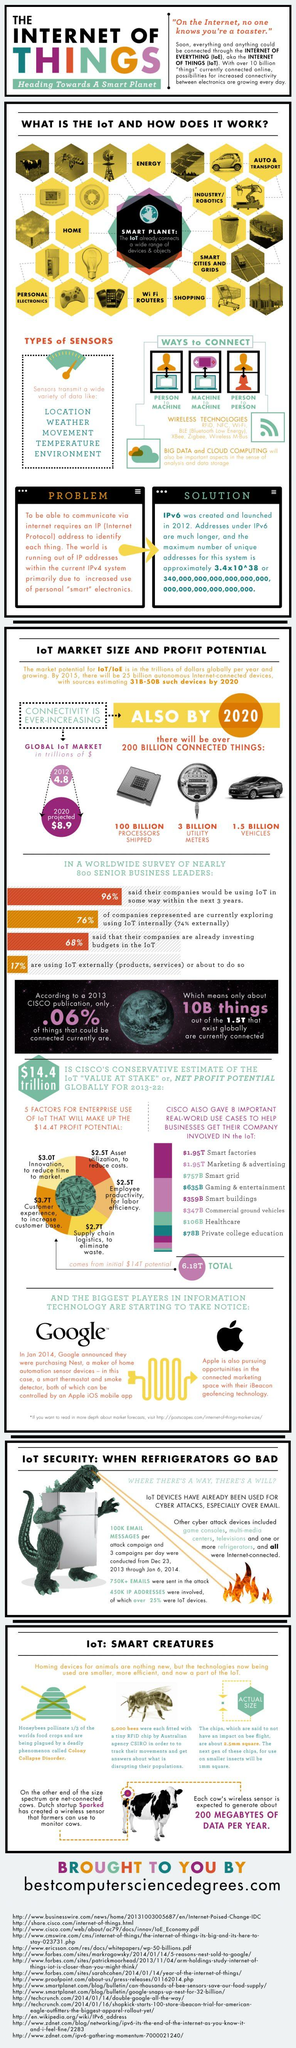Point out several critical features in this image. The third type of data sensors transmit in this infographic is movement. There are approximately 3 billion utility meters in use worldwide. The second variety of data sensors transmit in the infographic is weather information. There are multiple types of data sensors that transmit information. The exact number is unknown, but it is estimated to be around 5. The infographic contains seven wireless technologies. 